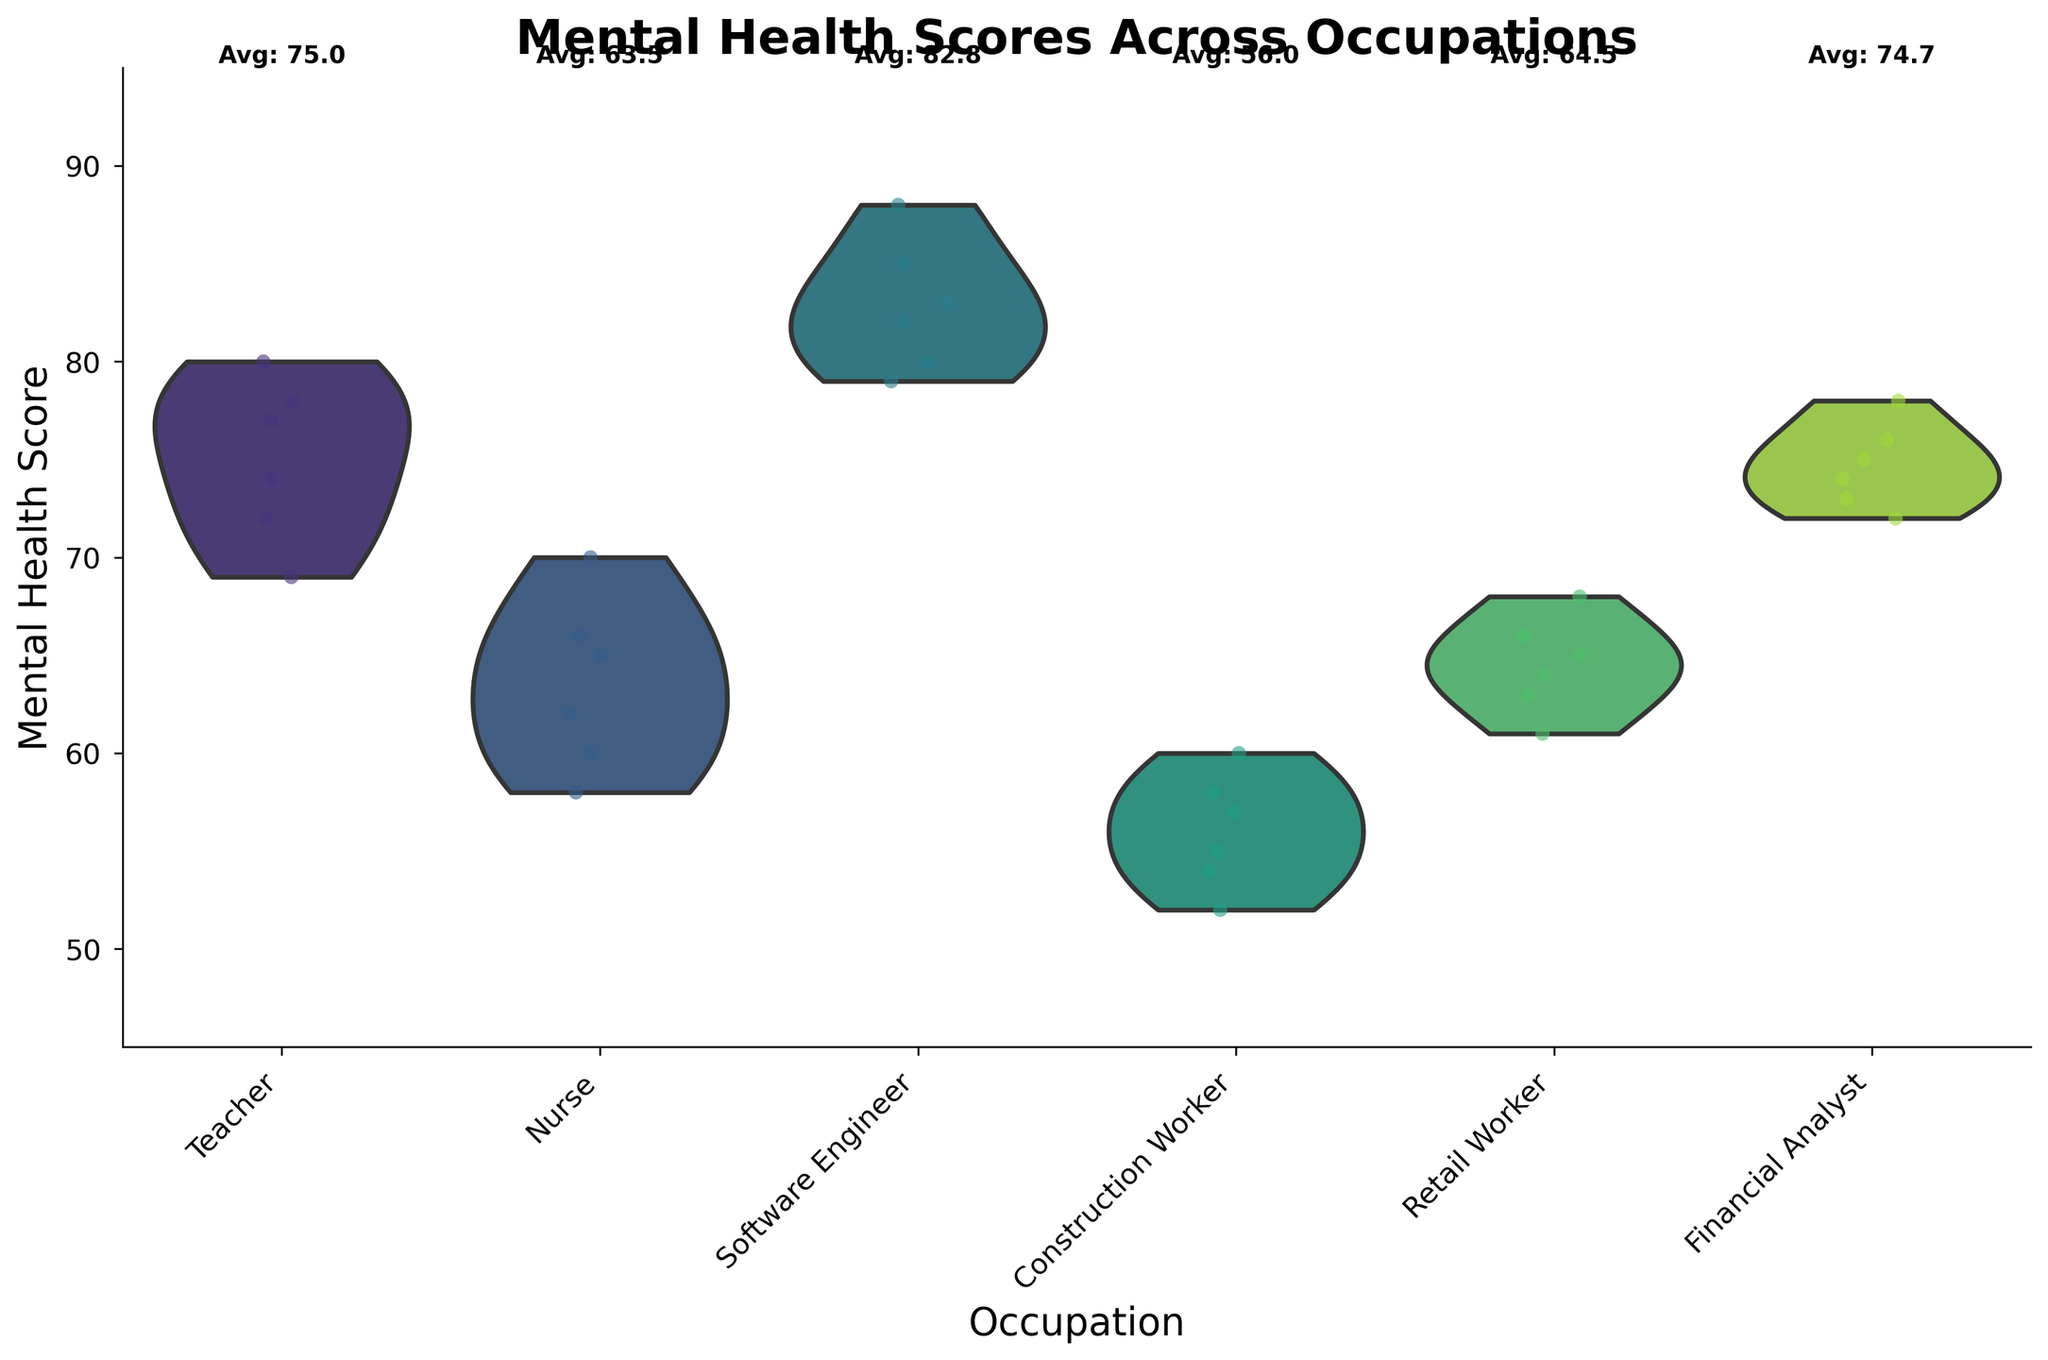What's the title of the figure? The title of the figure is found at the top and provides an overview of what the chart represents.
Answer: Mental Health Scores Across Occupations What are the labels on the x-axis and y-axis? The axis labels describe what each axis represents; the x-axis shows different occupations and the y-axis shows mental health scores.
Answer: Occupation, Mental Health Score Which occupation has the highest average mental health score? By looking for the text label 'Avg:' above each occupation's violin plot, we can identify the highest average score.
Answer: Software Engineer What is the average mental health score for retail workers? Locate the 'Avg:' text above the violin plot for retail workers to find their average score.
Answer: 64.5 Which occupation has the widest spread in mental health scores? The spread is indicated by the width of the violin plot. Comparing all, the one with the widest plot has the widest spread.
Answer: Nurse Which occupation has the most clustered data points on the violin plot? Examining the jittered points, the occupation where the points are closest together represents the most clustered data.
Answer: Software Engineer How do the mental health scores of construction workers compare to those of financial analysts? Compare the violin plots and jittered points of both occupations to see how scores overlap or differ.
Answer: Construction Workers have lower scores overall Which occupation has the lowest minimum mental health score? Identify the lowest point on the y-axis where the jittered points appear for each occupation.
Answer: Nurse What is the range of mental health scores for teachers? The range is the difference between the highest and lowest points of the violin plot for teachers.
Answer: 69 to 80 What can you infer about the variability of mental health scores among teachers and nurses? Compare the shapes of the violin plots; a wider plot indicates higher variability.
Answer: Nurses show higher variability than teachers 